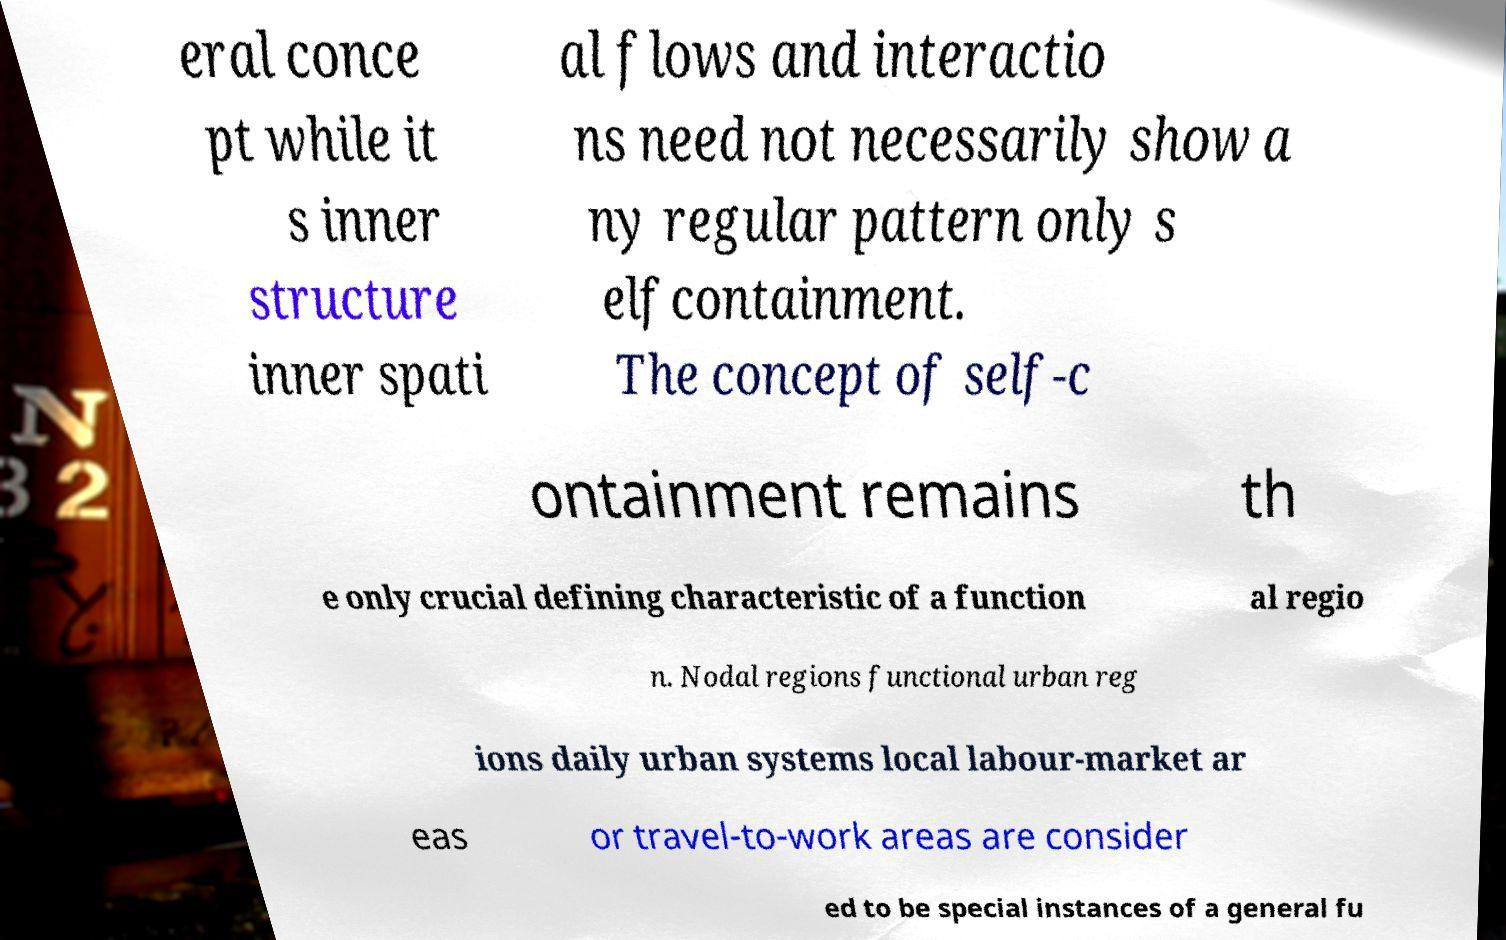Can you accurately transcribe the text from the provided image for me? eral conce pt while it s inner structure inner spati al flows and interactio ns need not necessarily show a ny regular pattern only s elfcontainment. The concept of self-c ontainment remains th e only crucial defining characteristic of a function al regio n. Nodal regions functional urban reg ions daily urban systems local labour-market ar eas or travel-to-work areas are consider ed to be special instances of a general fu 